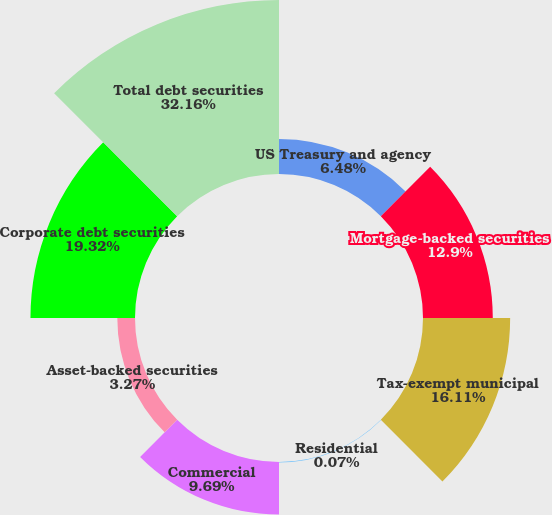<chart> <loc_0><loc_0><loc_500><loc_500><pie_chart><fcel>US Treasury and agency<fcel>Mortgage-backed securities<fcel>Tax-exempt municipal<fcel>Residential<fcel>Commercial<fcel>Asset-backed securities<fcel>Corporate debt securities<fcel>Total debt securities<nl><fcel>6.48%<fcel>12.9%<fcel>16.11%<fcel>0.07%<fcel>9.69%<fcel>3.27%<fcel>19.32%<fcel>32.16%<nl></chart> 